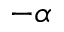<formula> <loc_0><loc_0><loc_500><loc_500>- \alpha</formula> 